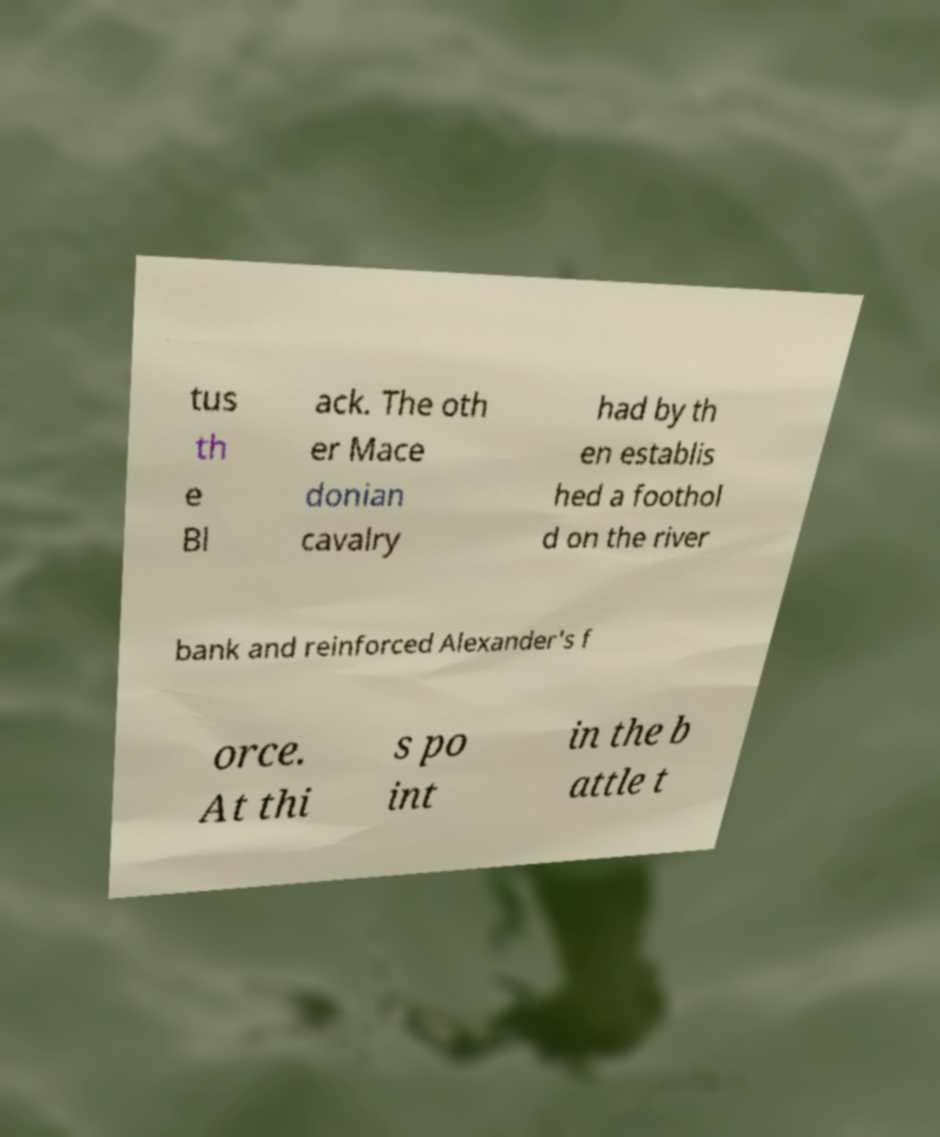Please identify and transcribe the text found in this image. tus th e Bl ack. The oth er Mace donian cavalry had by th en establis hed a foothol d on the river bank and reinforced Alexander's f orce. At thi s po int in the b attle t 